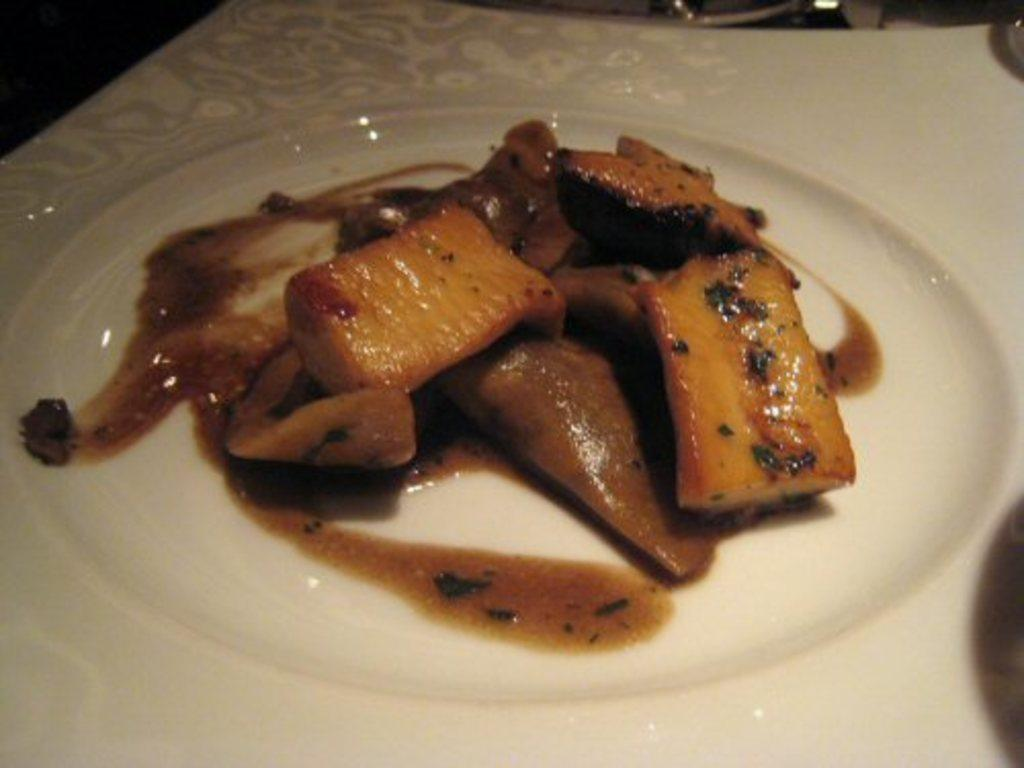What is present on the plate in the image? There is a food item on the plate in the image. Can you describe the food item on the plate? Unfortunately, the provided facts do not specify the type of food item on the plate. Can you see an ant carrying a piece of the food item on the plate in the image? There is no mention of an ant or any other insects in the image, so it cannot be determined if an ant is carrying a piece of the food item. 